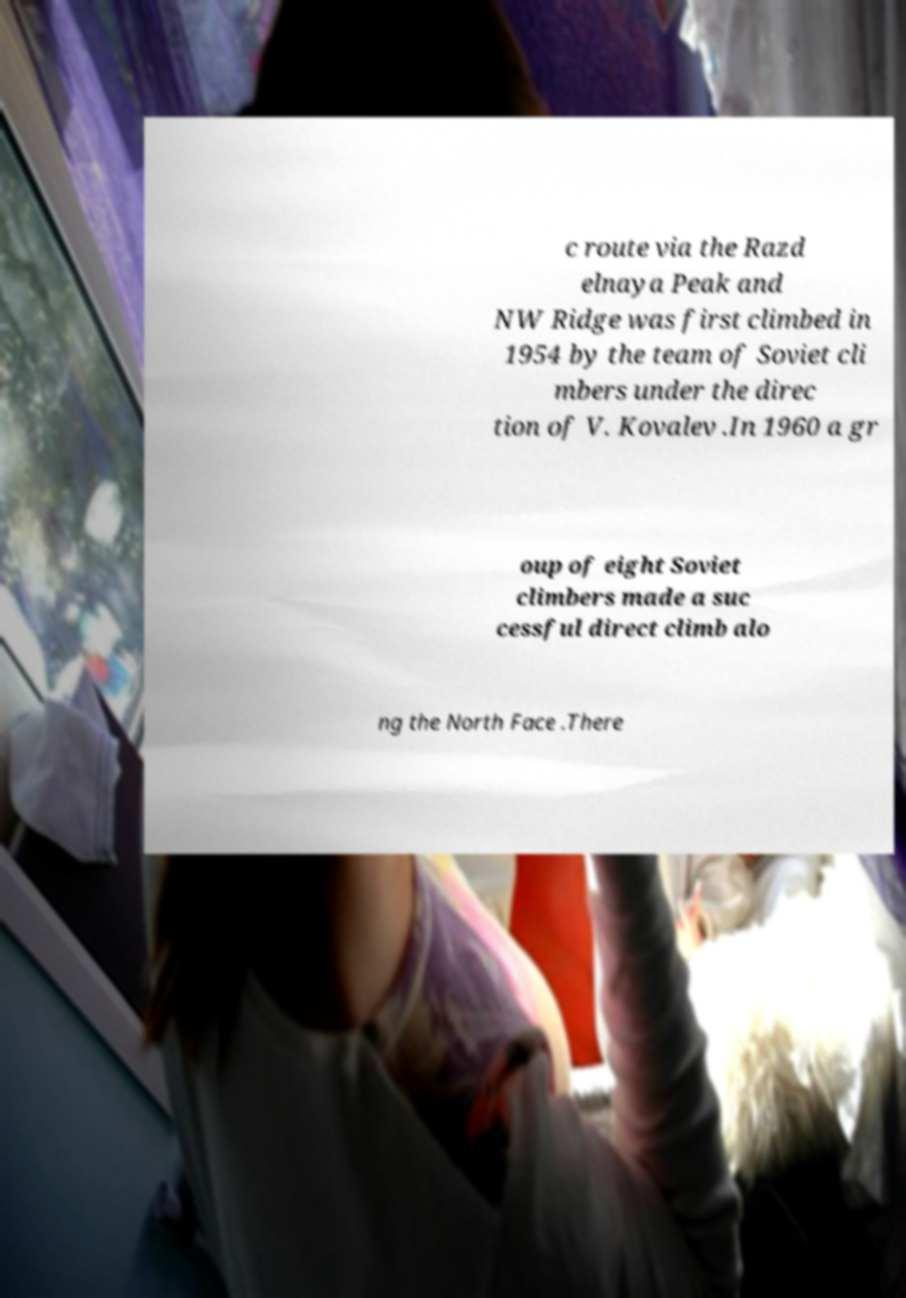What messages or text are displayed in this image? I need them in a readable, typed format. c route via the Razd elnaya Peak and NW Ridge was first climbed in 1954 by the team of Soviet cli mbers under the direc tion of V. Kovalev .In 1960 a gr oup of eight Soviet climbers made a suc cessful direct climb alo ng the North Face .There 